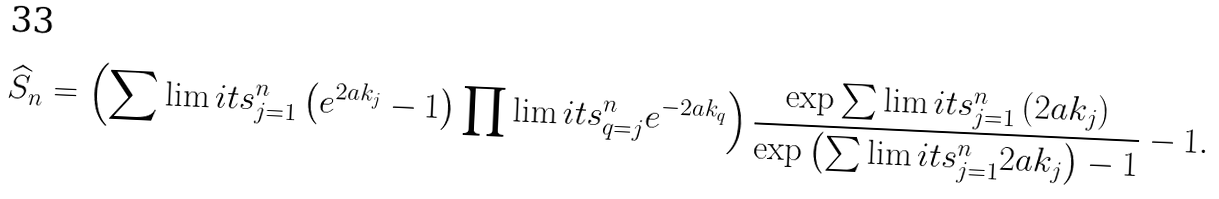<formula> <loc_0><loc_0><loc_500><loc_500>\widehat { S } _ { n } = \left ( \sum \lim i t s _ { j = 1 } ^ { n } \left ( e ^ { 2 a k _ { j } } - 1 \right ) \prod \lim i t s _ { q = j } ^ { n } e ^ { - 2 a k _ { q } } \right ) \frac { \exp \sum \lim i t s _ { j = 1 } ^ { n } \left ( 2 a k _ { j } \right ) } { \exp \left ( \sum \lim i t s _ { j = 1 } ^ { n } 2 a k _ { j } \right ) - 1 } - 1 .</formula> 